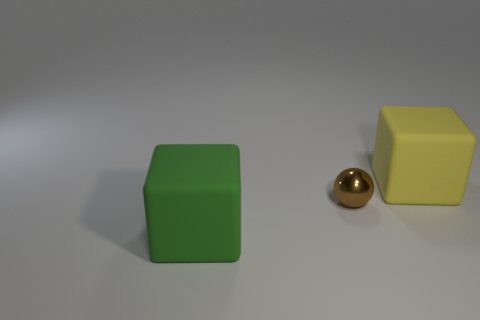Add 2 large yellow balls. How many objects exist? 5 Subtract all cubes. How many objects are left? 1 Add 3 small metal things. How many small metal things exist? 4 Subtract 0 gray cylinders. How many objects are left? 3 Subtract all tiny blue metal cylinders. Subtract all small brown metallic spheres. How many objects are left? 2 Add 3 brown spheres. How many brown spheres are left? 4 